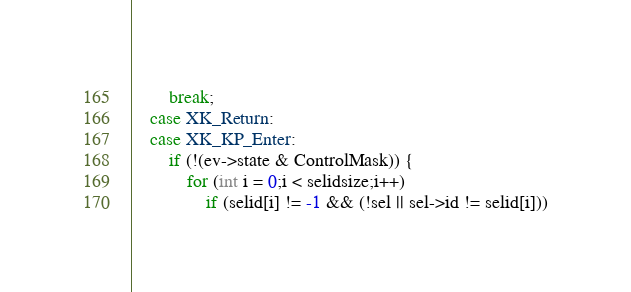<code> <loc_0><loc_0><loc_500><loc_500><_C_>		break;
	case XK_Return:
	case XK_KP_Enter:
		if (!(ev->state & ControlMask)) {
			for (int i = 0;i < selidsize;i++)
				if (selid[i] != -1 && (!sel || sel->id != selid[i]))</code> 